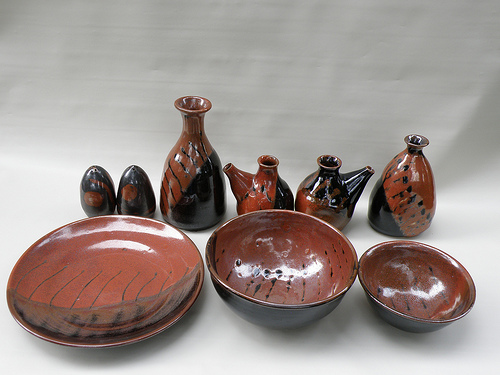Please provide the bounding box coordinate of the region this sentence describes: these have designs on them. The coordinates for the region described as 'these have designs on them' are [0.55, 0.66, 0.68, 0.78]. This area showcases items with distinctive patterns. 